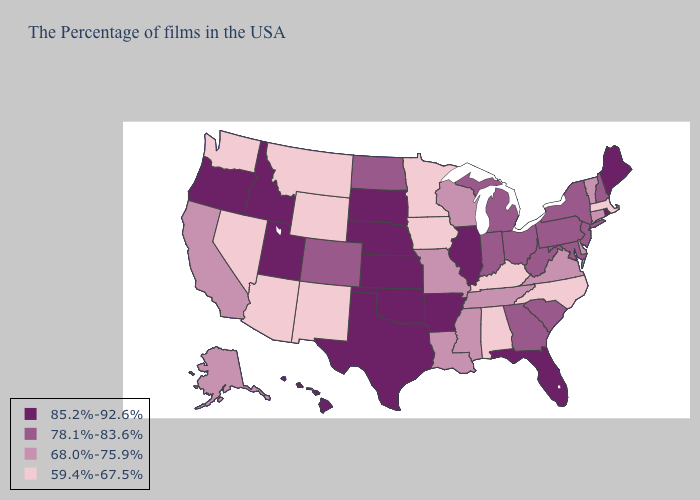What is the lowest value in states that border Wyoming?
Answer briefly. 59.4%-67.5%. Does Kansas have the highest value in the MidWest?
Short answer required. Yes. Name the states that have a value in the range 59.4%-67.5%?
Short answer required. Massachusetts, North Carolina, Kentucky, Alabama, Minnesota, Iowa, Wyoming, New Mexico, Montana, Arizona, Nevada, Washington. What is the highest value in states that border Massachusetts?
Answer briefly. 85.2%-92.6%. Does New York have a higher value than Pennsylvania?
Quick response, please. No. Which states have the highest value in the USA?
Concise answer only. Maine, Rhode Island, Florida, Illinois, Arkansas, Kansas, Nebraska, Oklahoma, Texas, South Dakota, Utah, Idaho, Oregon, Hawaii. Among the states that border South Carolina , does Georgia have the lowest value?
Be succinct. No. Does the first symbol in the legend represent the smallest category?
Short answer required. No. What is the highest value in states that border Connecticut?
Concise answer only. 85.2%-92.6%. Name the states that have a value in the range 78.1%-83.6%?
Be succinct. New Hampshire, New York, New Jersey, Maryland, Pennsylvania, South Carolina, West Virginia, Ohio, Georgia, Michigan, Indiana, North Dakota, Colorado. What is the value of Virginia?
Be succinct. 68.0%-75.9%. What is the value of Tennessee?
Be succinct. 68.0%-75.9%. What is the value of Massachusetts?
Answer briefly. 59.4%-67.5%. What is the highest value in states that border South Carolina?
Quick response, please. 78.1%-83.6%. How many symbols are there in the legend?
Answer briefly. 4. 